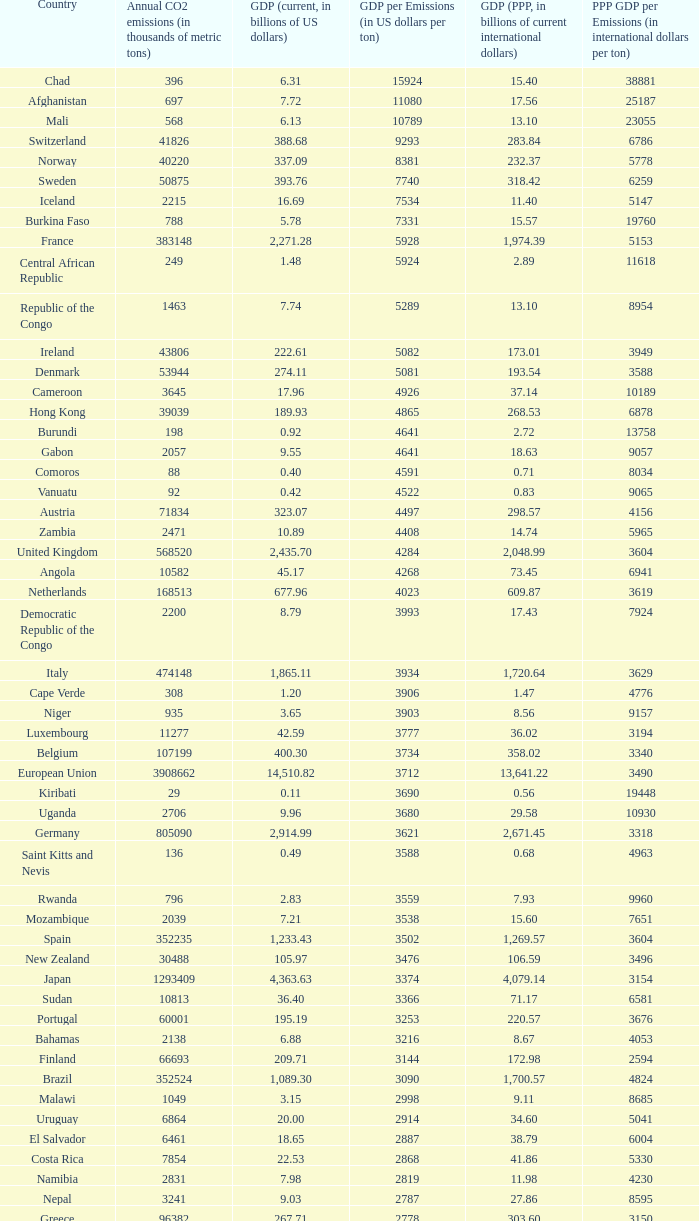At a gdp per emissions rate of $3,903 per ton, what is the upper limit for annual co2 emissions measured in thousands of metric tons? 935.0. 